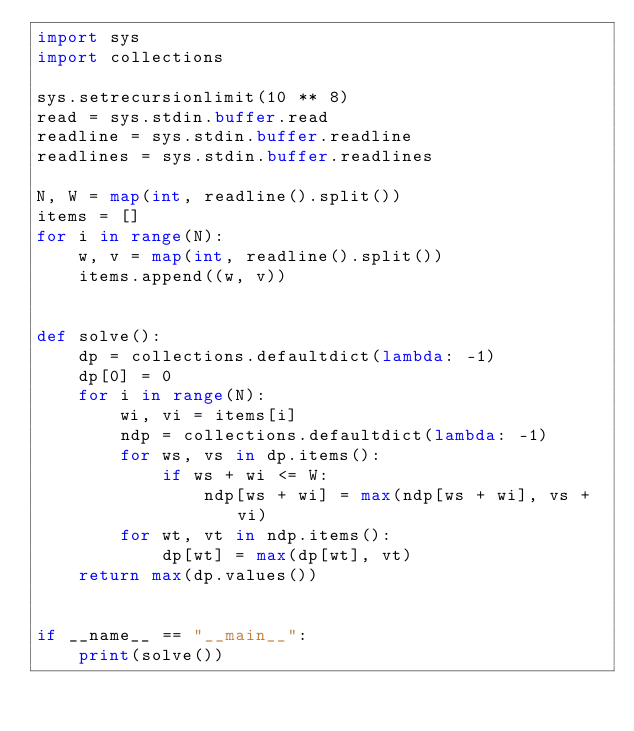Convert code to text. <code><loc_0><loc_0><loc_500><loc_500><_Python_>import sys
import collections

sys.setrecursionlimit(10 ** 8)
read = sys.stdin.buffer.read
readline = sys.stdin.buffer.readline
readlines = sys.stdin.buffer.readlines

N, W = map(int, readline().split())
items = []
for i in range(N):
    w, v = map(int, readline().split())
    items.append((w, v))


def solve():
    dp = collections.defaultdict(lambda: -1)
    dp[0] = 0
    for i in range(N):
        wi, vi = items[i]
        ndp = collections.defaultdict(lambda: -1)
        for ws, vs in dp.items():
            if ws + wi <= W:
                ndp[ws + wi] = max(ndp[ws + wi], vs + vi)
        for wt, vt in ndp.items():
            dp[wt] = max(dp[wt], vt)
    return max(dp.values())


if __name__ == "__main__":
    print(solve())
</code> 